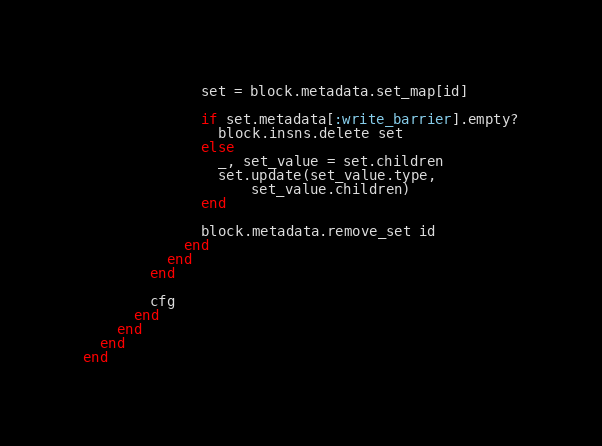<code> <loc_0><loc_0><loc_500><loc_500><_Ruby_>              set = block.metadata.set_map[id]

              if set.metadata[:write_barrier].empty?
                block.insns.delete set
              else
                _, set_value = set.children
                set.update(set_value.type,
                    set_value.children)
              end

              block.metadata.remove_set id
            end
          end
        end

        cfg
      end
    end
  end
end</code> 